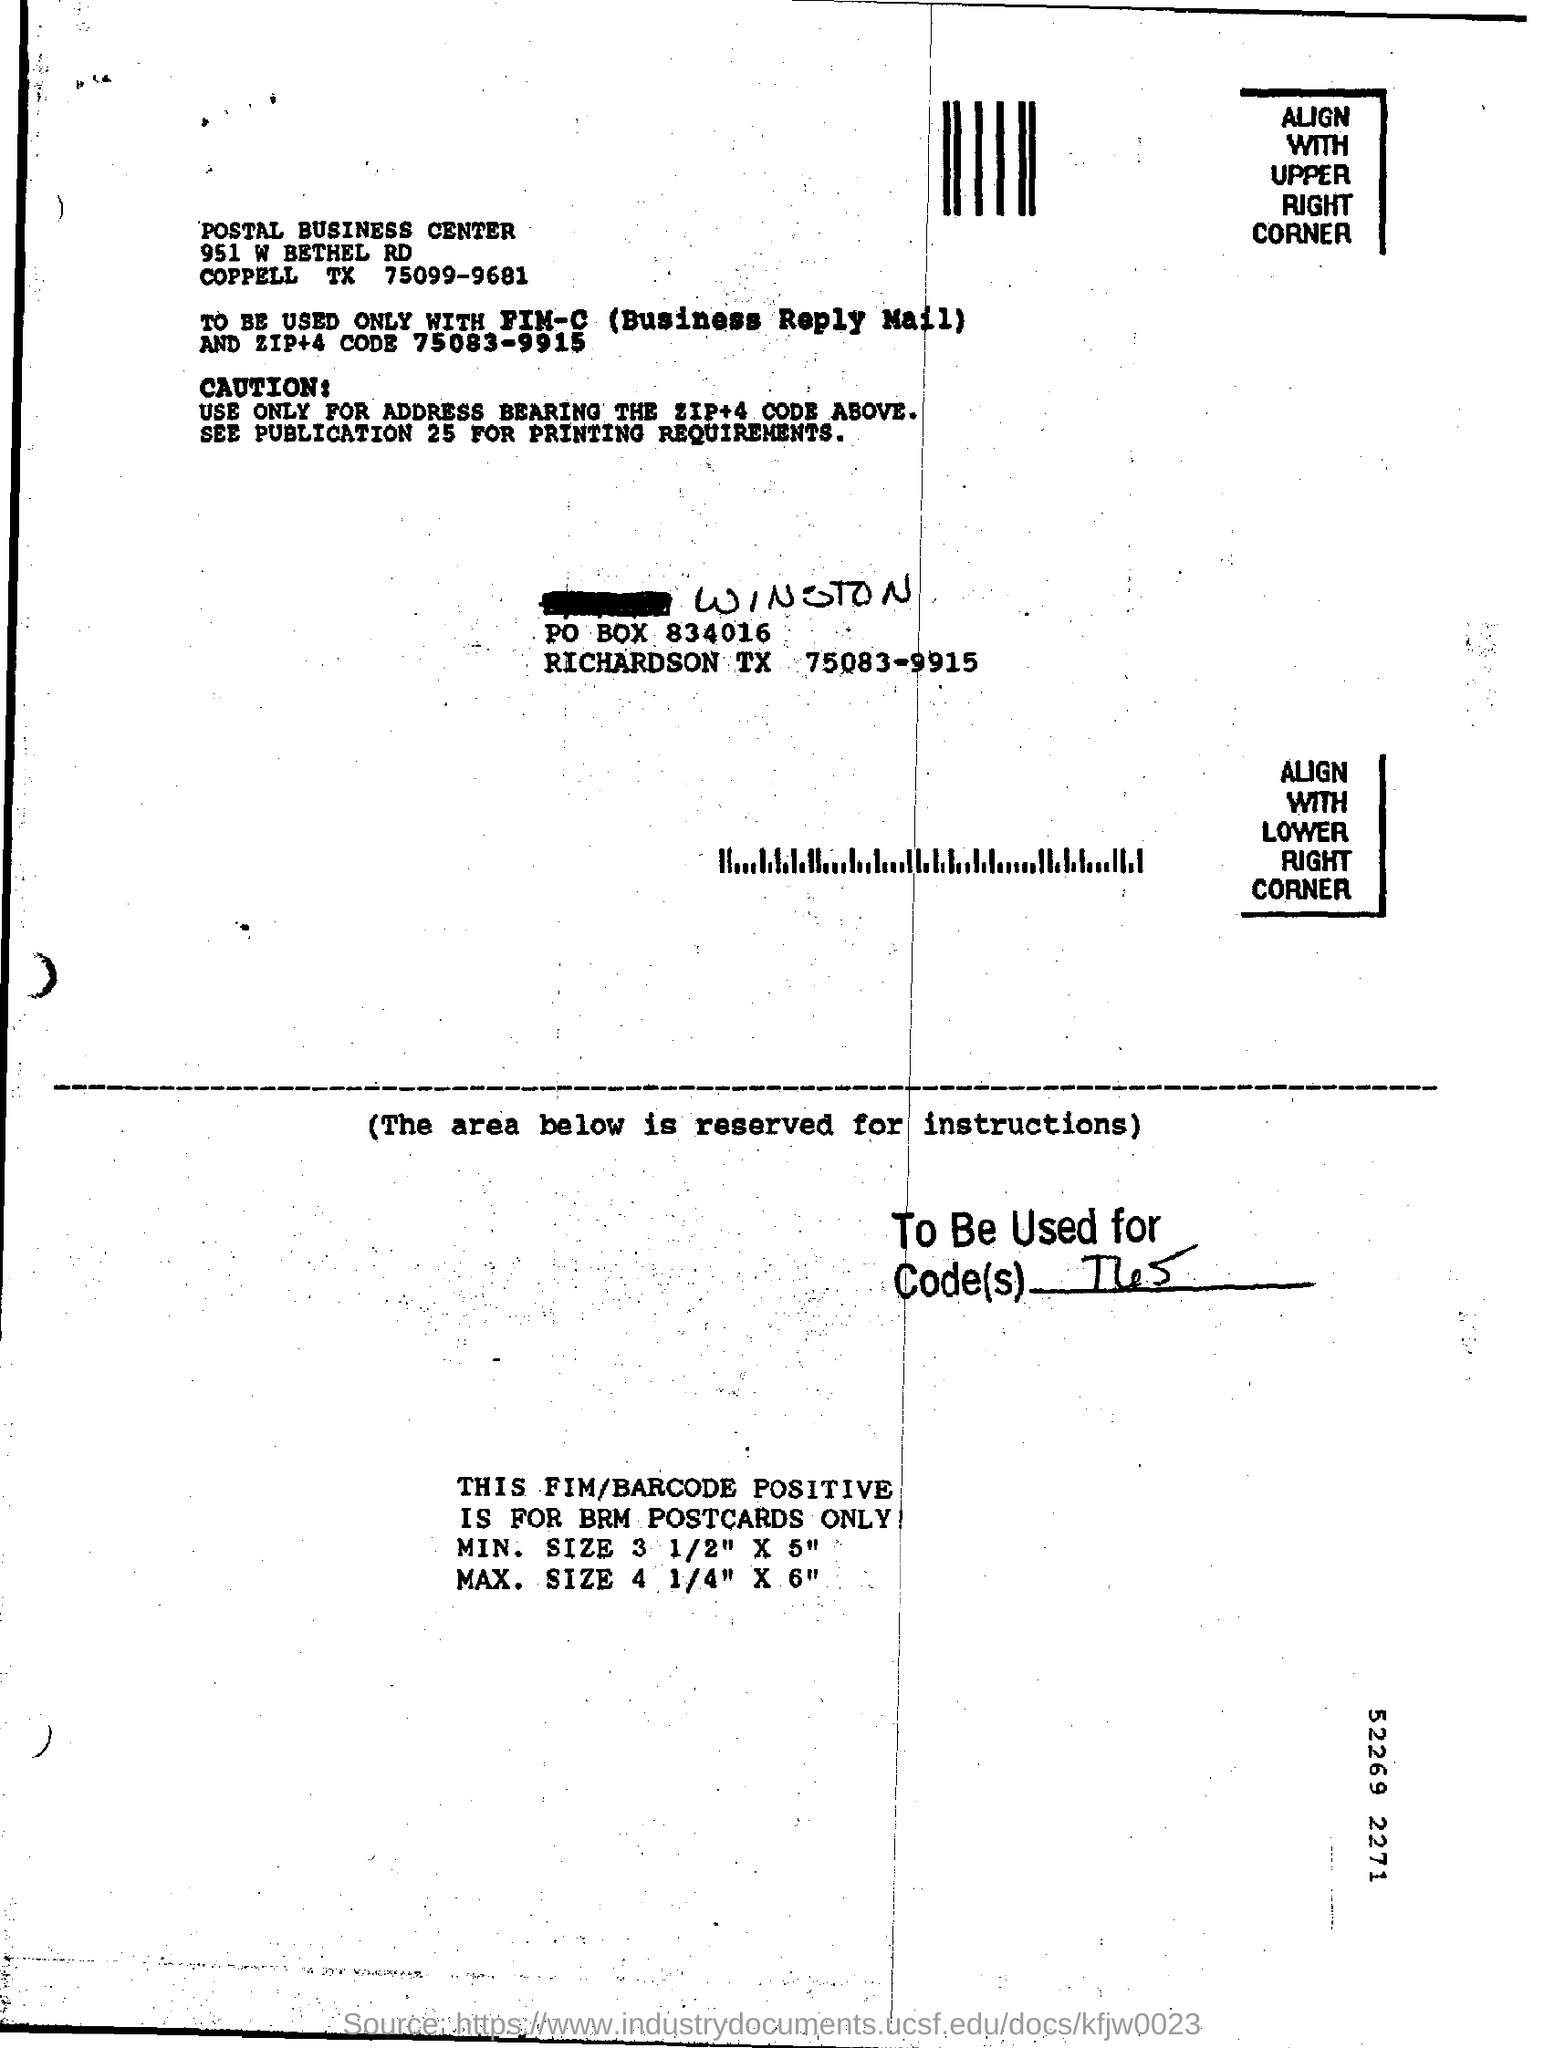What is the center's name mentioned?
Your response must be concise. POSTAL BUSINESS CENTER. 